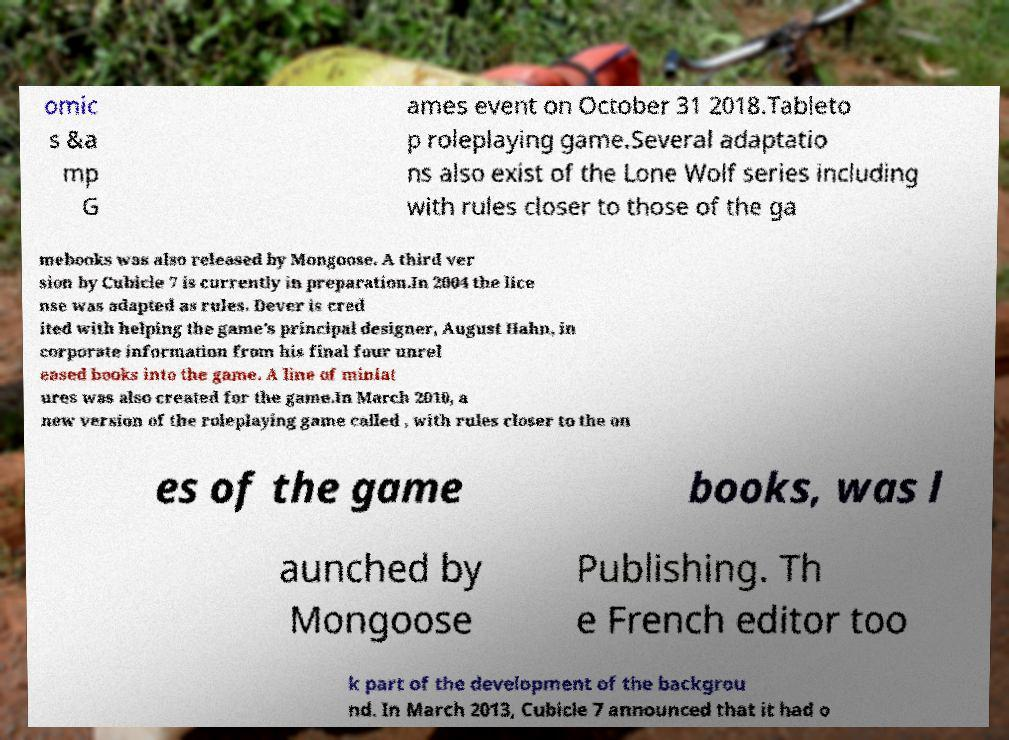Can you read and provide the text displayed in the image?This photo seems to have some interesting text. Can you extract and type it out for me? omic s &a mp G ames event on October 31 2018.Tableto p roleplaying game.Several adaptatio ns also exist of the Lone Wolf series including with rules closer to those of the ga mebooks was also released by Mongoose. A third ver sion by Cubicle 7 is currently in preparation.In 2004 the lice nse was adapted as rules. Dever is cred ited with helping the game's principal designer, August Hahn, in corporate information from his final four unrel eased books into the game. A line of miniat ures was also created for the game.In March 2010, a new version of the roleplaying game called , with rules closer to the on es of the game books, was l aunched by Mongoose Publishing. Th e French editor too k part of the development of the backgrou nd. In March 2013, Cubicle 7 announced that it had o 